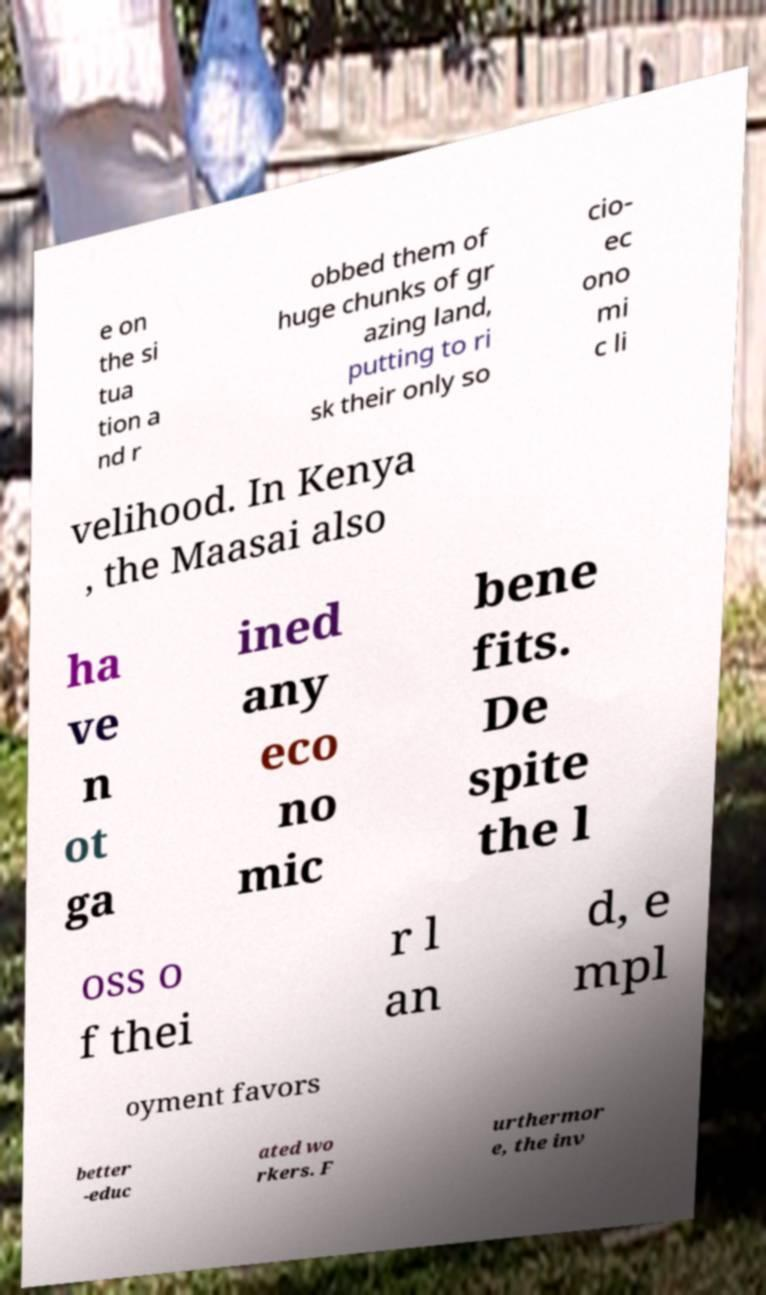Could you assist in decoding the text presented in this image and type it out clearly? e on the si tua tion a nd r obbed them of huge chunks of gr azing land, putting to ri sk their only so cio- ec ono mi c li velihood. In Kenya , the Maasai also ha ve n ot ga ined any eco no mic bene fits. De spite the l oss o f thei r l an d, e mpl oyment favors better -educ ated wo rkers. F urthermor e, the inv 